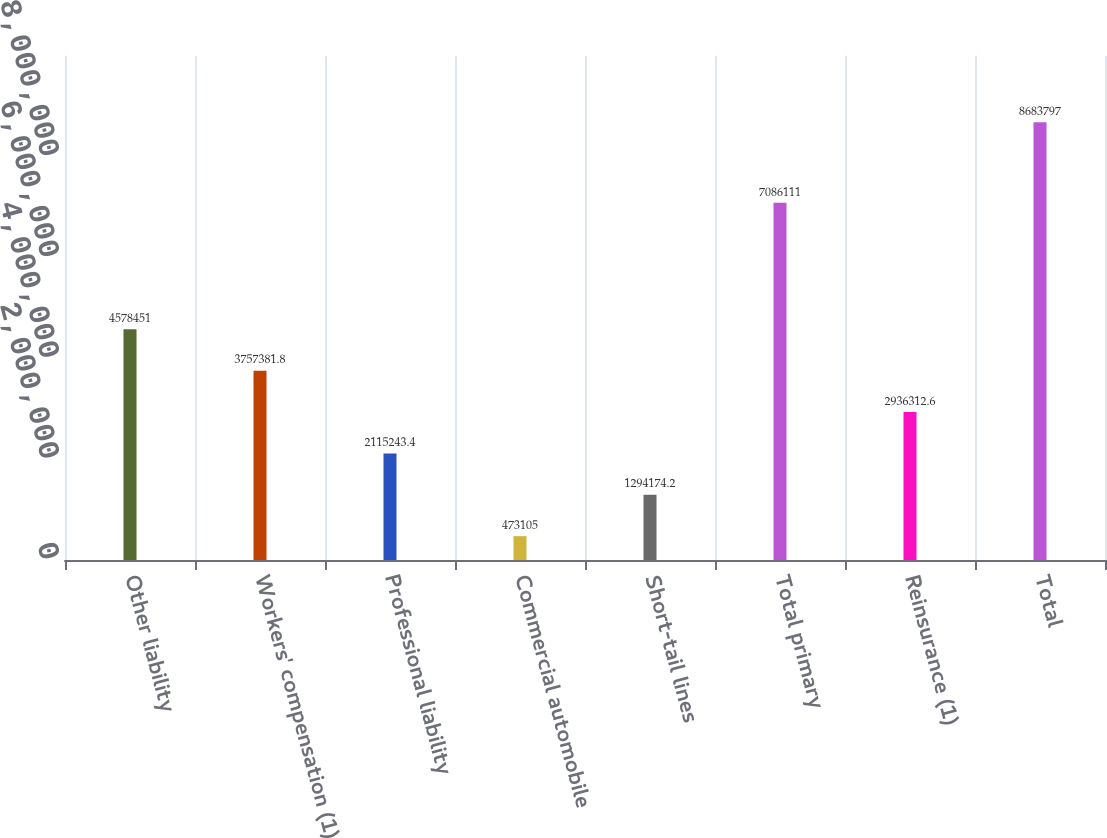<chart> <loc_0><loc_0><loc_500><loc_500><bar_chart><fcel>Other liability<fcel>Workers' compensation (1)<fcel>Professional liability<fcel>Commercial automobile<fcel>Short-tail lines<fcel>Total primary<fcel>Reinsurance (1)<fcel>Total<nl><fcel>4.57845e+06<fcel>3.75738e+06<fcel>2.11524e+06<fcel>473105<fcel>1.29417e+06<fcel>7.08611e+06<fcel>2.93631e+06<fcel>8.6838e+06<nl></chart> 